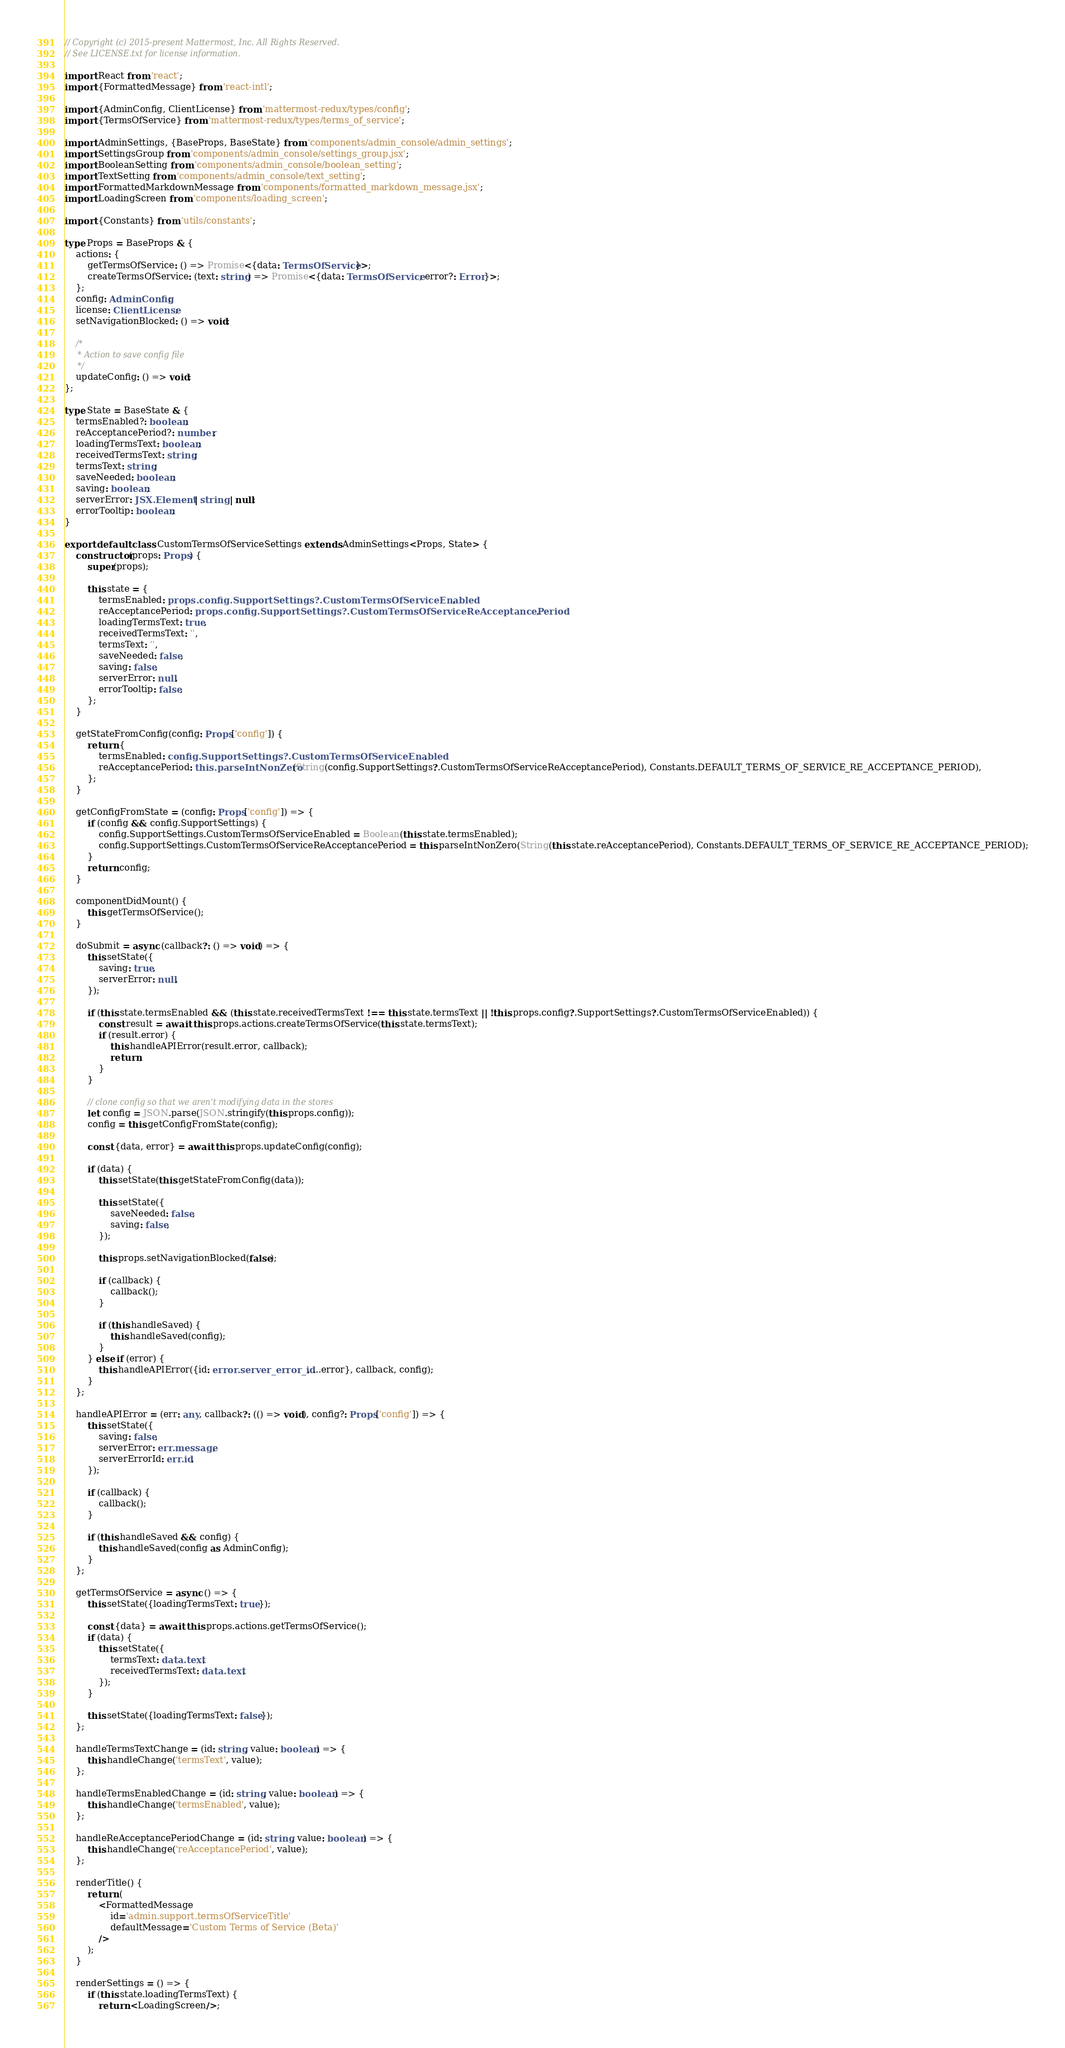Convert code to text. <code><loc_0><loc_0><loc_500><loc_500><_TypeScript_>// Copyright (c) 2015-present Mattermost, Inc. All Rights Reserved.
// See LICENSE.txt for license information.

import React from 'react';
import {FormattedMessage} from 'react-intl';

import {AdminConfig, ClientLicense} from 'mattermost-redux/types/config';
import {TermsOfService} from 'mattermost-redux/types/terms_of_service';

import AdminSettings, {BaseProps, BaseState} from 'components/admin_console/admin_settings';
import SettingsGroup from 'components/admin_console/settings_group.jsx';
import BooleanSetting from 'components/admin_console/boolean_setting';
import TextSetting from 'components/admin_console/text_setting';
import FormattedMarkdownMessage from 'components/formatted_markdown_message.jsx';
import LoadingScreen from 'components/loading_screen';

import {Constants} from 'utils/constants';

type Props = BaseProps & {
    actions: {
        getTermsOfService: () => Promise<{data: TermsOfService}>;
        createTermsOfService: (text: string) => Promise<{data: TermsOfService; error?: Error}>;
    };
    config: AdminConfig;
    license: ClientLicense;
    setNavigationBlocked: () => void;

    /*
     * Action to save config file
     */
    updateConfig: () => void;
};

type State = BaseState & {
    termsEnabled?: boolean;
    reAcceptancePeriod?: number;
    loadingTermsText: boolean;
    receivedTermsText: string;
    termsText: string;
    saveNeeded: boolean;
    saving: boolean;
    serverError: JSX.Element | string | null;
    errorTooltip: boolean;
}

export default class CustomTermsOfServiceSettings extends AdminSettings<Props, State> {
    constructor(props: Props) {
        super(props);

        this.state = {
            termsEnabled: props.config.SupportSettings?.CustomTermsOfServiceEnabled,
            reAcceptancePeriod: props.config.SupportSettings?.CustomTermsOfServiceReAcceptancePeriod,
            loadingTermsText: true,
            receivedTermsText: '',
            termsText: '',
            saveNeeded: false,
            saving: false,
            serverError: null,
            errorTooltip: false,
        };
    }

    getStateFromConfig(config: Props['config']) {
        return {
            termsEnabled: config.SupportSettings?.CustomTermsOfServiceEnabled,
            reAcceptancePeriod: this.parseIntNonZero(String(config.SupportSettings?.CustomTermsOfServiceReAcceptancePeriod), Constants.DEFAULT_TERMS_OF_SERVICE_RE_ACCEPTANCE_PERIOD),
        };
    }

    getConfigFromState = (config: Props['config']) => {
        if (config && config.SupportSettings) {
            config.SupportSettings.CustomTermsOfServiceEnabled = Boolean(this.state.termsEnabled);
            config.SupportSettings.CustomTermsOfServiceReAcceptancePeriod = this.parseIntNonZero(String(this.state.reAcceptancePeriod), Constants.DEFAULT_TERMS_OF_SERVICE_RE_ACCEPTANCE_PERIOD);
        }
        return config;
    }

    componentDidMount() {
        this.getTermsOfService();
    }

    doSubmit = async (callback?: () => void) => {
        this.setState({
            saving: true,
            serverError: null,
        });

        if (this.state.termsEnabled && (this.state.receivedTermsText !== this.state.termsText || !this.props.config?.SupportSettings?.CustomTermsOfServiceEnabled)) {
            const result = await this.props.actions.createTermsOfService(this.state.termsText);
            if (result.error) {
                this.handleAPIError(result.error, callback);
                return;
            }
        }

        // clone config so that we aren't modifying data in the stores
        let config = JSON.parse(JSON.stringify(this.props.config));
        config = this.getConfigFromState(config);

        const {data, error} = await this.props.updateConfig(config);

        if (data) {
            this.setState(this.getStateFromConfig(data));

            this.setState({
                saveNeeded: false,
                saving: false,
            });

            this.props.setNavigationBlocked(false);

            if (callback) {
                callback();
            }

            if (this.handleSaved) {
                this.handleSaved(config);
            }
        } else if (error) {
            this.handleAPIError({id: error.server_error_id, ...error}, callback, config);
        }
    };

    handleAPIError = (err: any, callback?: (() => void), config?: Props['config']) => {
        this.setState({
            saving: false,
            serverError: err.message,
            serverErrorId: err.id,
        });

        if (callback) {
            callback();
        }

        if (this.handleSaved && config) {
            this.handleSaved(config as AdminConfig);
        }
    };

    getTermsOfService = async () => {
        this.setState({loadingTermsText: true});

        const {data} = await this.props.actions.getTermsOfService();
        if (data) {
            this.setState({
                termsText: data.text,
                receivedTermsText: data.text,
            });
        }

        this.setState({loadingTermsText: false});
    };

    handleTermsTextChange = (id: string, value: boolean) => {
        this.handleChange('termsText', value);
    };

    handleTermsEnabledChange = (id: string, value: boolean) => {
        this.handleChange('termsEnabled', value);
    };

    handleReAcceptancePeriodChange = (id: string, value: boolean) => {
        this.handleChange('reAcceptancePeriod', value);
    };

    renderTitle() {
        return (
            <FormattedMessage
                id='admin.support.termsOfServiceTitle'
                defaultMessage='Custom Terms of Service (Beta)'
            />
        );
    }

    renderSettings = () => {
        if (this.state.loadingTermsText) {
            return <LoadingScreen/>;</code> 